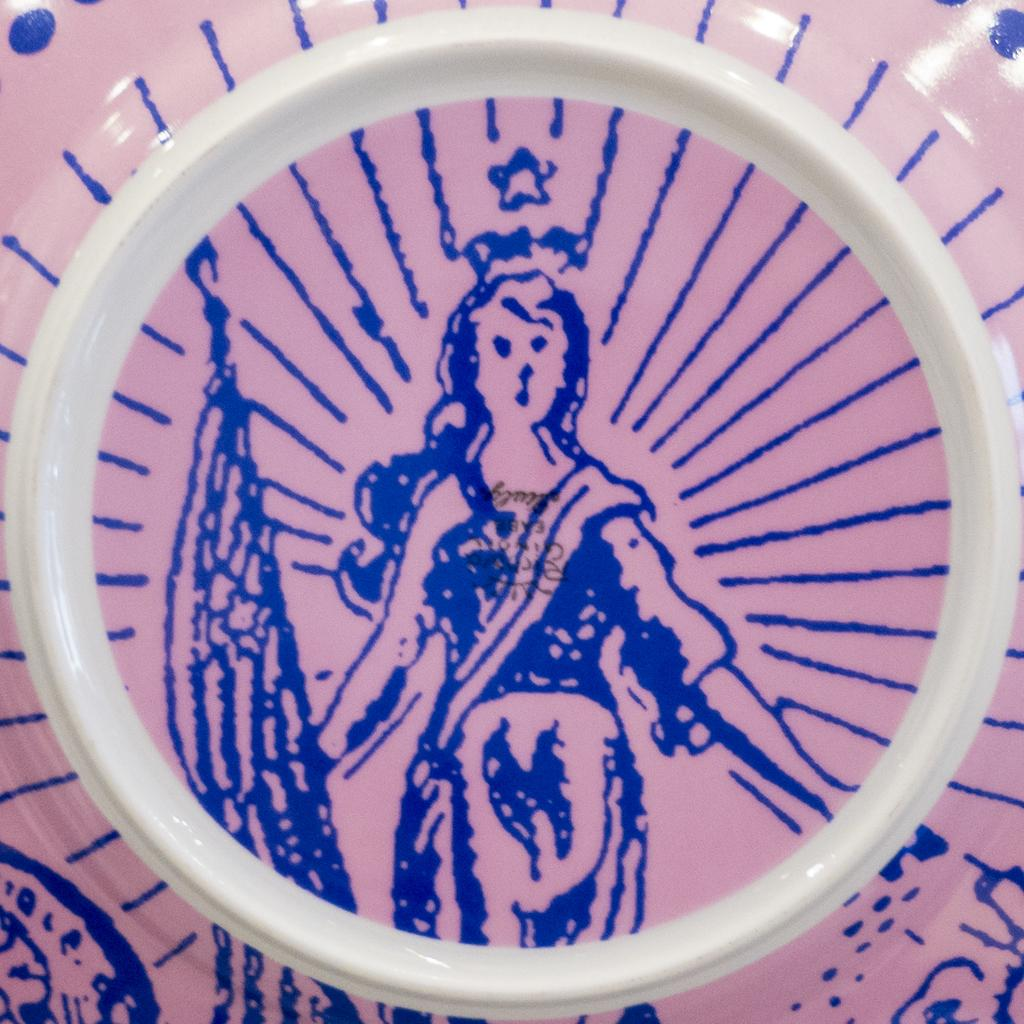What object can be seen in the image? There is a plate in the image. What type of hobbies does the tiger have in the image? There is no tiger present in the image, so it is not possible to determine its hobbies. 